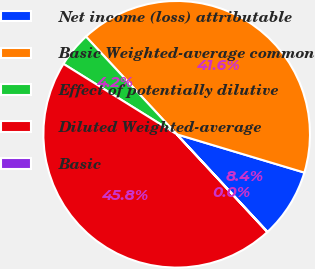Convert chart to OTSL. <chart><loc_0><loc_0><loc_500><loc_500><pie_chart><fcel>Net income (loss) attributable<fcel>Basic Weighted-average common<fcel>Effect of potentially dilutive<fcel>Diluted Weighted-average<fcel>Basic<nl><fcel>8.43%<fcel>41.55%<fcel>4.23%<fcel>45.75%<fcel>0.03%<nl></chart> 